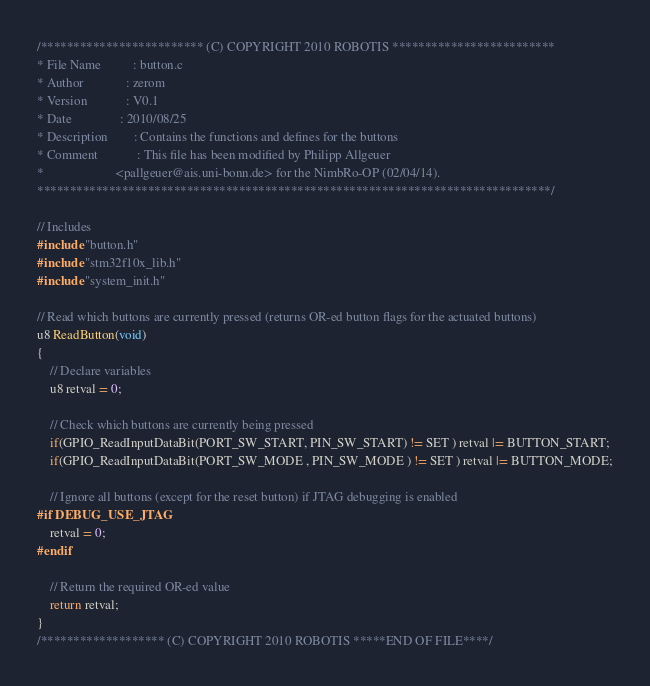Convert code to text. <code><loc_0><loc_0><loc_500><loc_500><_C_>/************************* (C) COPYRIGHT 2010 ROBOTIS *************************
* File Name          : button.c
* Author             : zerom
* Version            : V0.1
* Date               : 2010/08/25
* Description        : Contains the functions and defines for the buttons
* Comment            : This file has been modified by Philipp Allgeuer
*                      <pallgeuer@ais.uni-bonn.de> for the NimbRo-OP (02/04/14).
*******************************************************************************/

// Includes
#include "button.h"
#include "stm32f10x_lib.h"
#include "system_init.h"

// Read which buttons are currently pressed (returns OR-ed button flags for the actuated buttons)
u8 ReadButton(void)
{
	// Declare variables
	u8 retval = 0;

	// Check which buttons are currently being pressed
	if(GPIO_ReadInputDataBit(PORT_SW_START, PIN_SW_START) != SET ) retval |= BUTTON_START;
	if(GPIO_ReadInputDataBit(PORT_SW_MODE , PIN_SW_MODE ) != SET ) retval |= BUTTON_MODE;

	// Ignore all buttons (except for the reset button) if JTAG debugging is enabled
#if DEBUG_USE_JTAG
	retval = 0;
#endif

	// Return the required OR-ed value
	return retval;
}
/******************* (C) COPYRIGHT 2010 ROBOTIS *****END OF FILE****/
</code> 